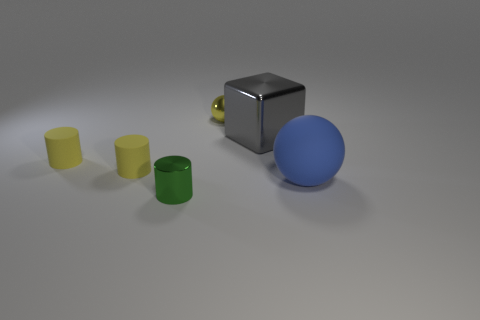Subtract 1 cylinders. How many cylinders are left? 2 Add 4 gray metal objects. How many objects exist? 10 Subtract all spheres. How many objects are left? 4 Add 6 green matte blocks. How many green matte blocks exist? 6 Subtract 0 cyan cylinders. How many objects are left? 6 Subtract all green metallic cylinders. Subtract all large metallic things. How many objects are left? 4 Add 2 rubber cylinders. How many rubber cylinders are left? 4 